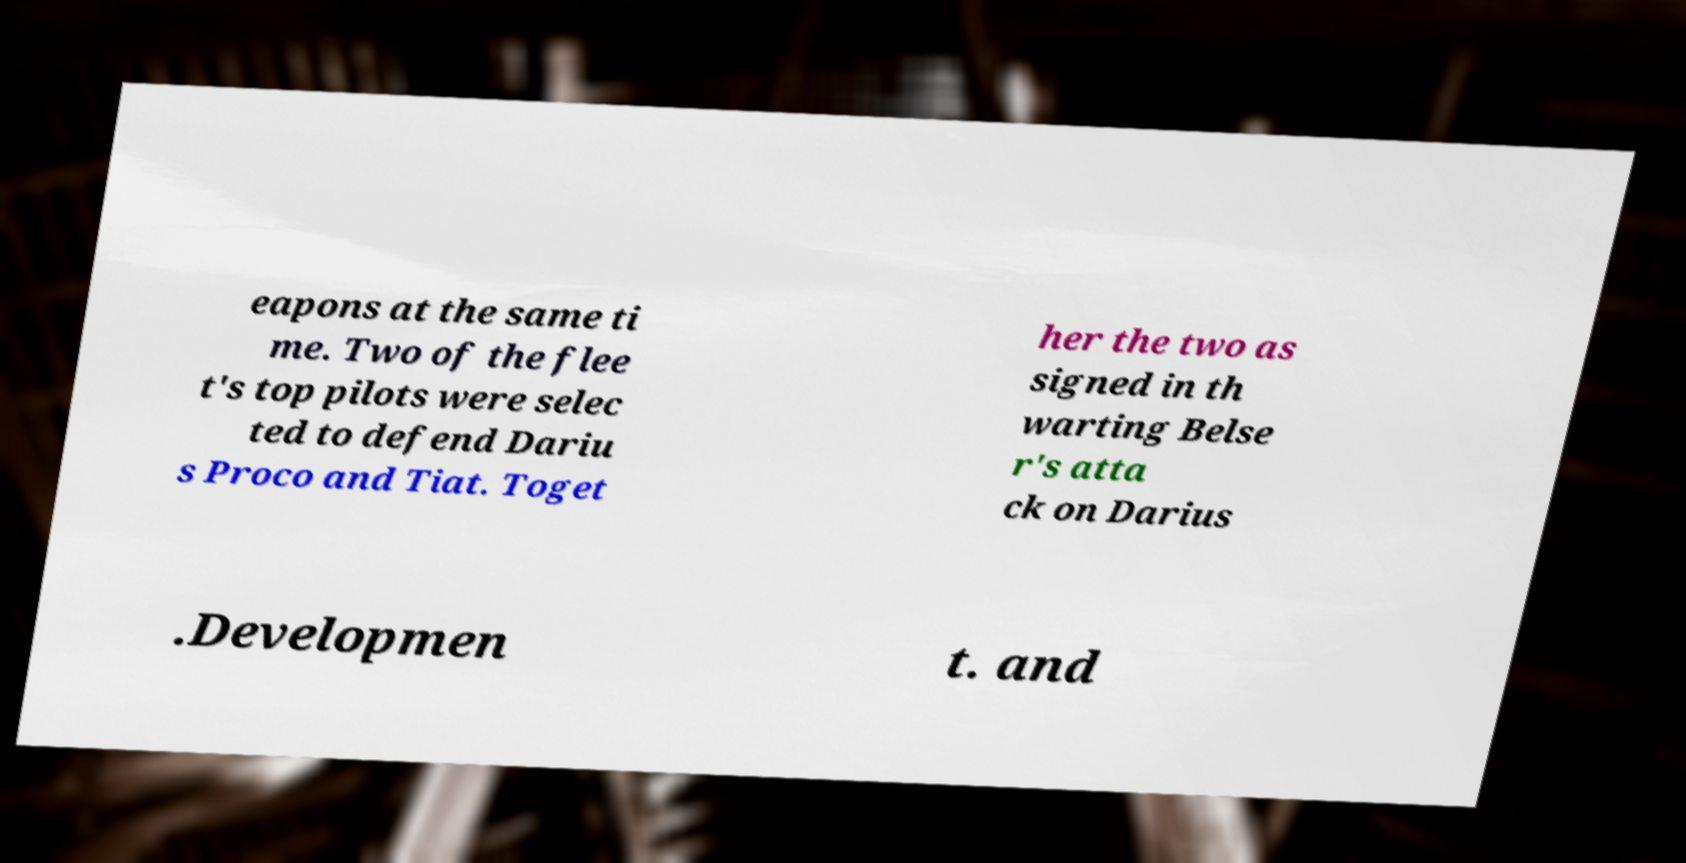For documentation purposes, I need the text within this image transcribed. Could you provide that? eapons at the same ti me. Two of the flee t's top pilots were selec ted to defend Dariu s Proco and Tiat. Toget her the two as signed in th warting Belse r's atta ck on Darius .Developmen t. and 